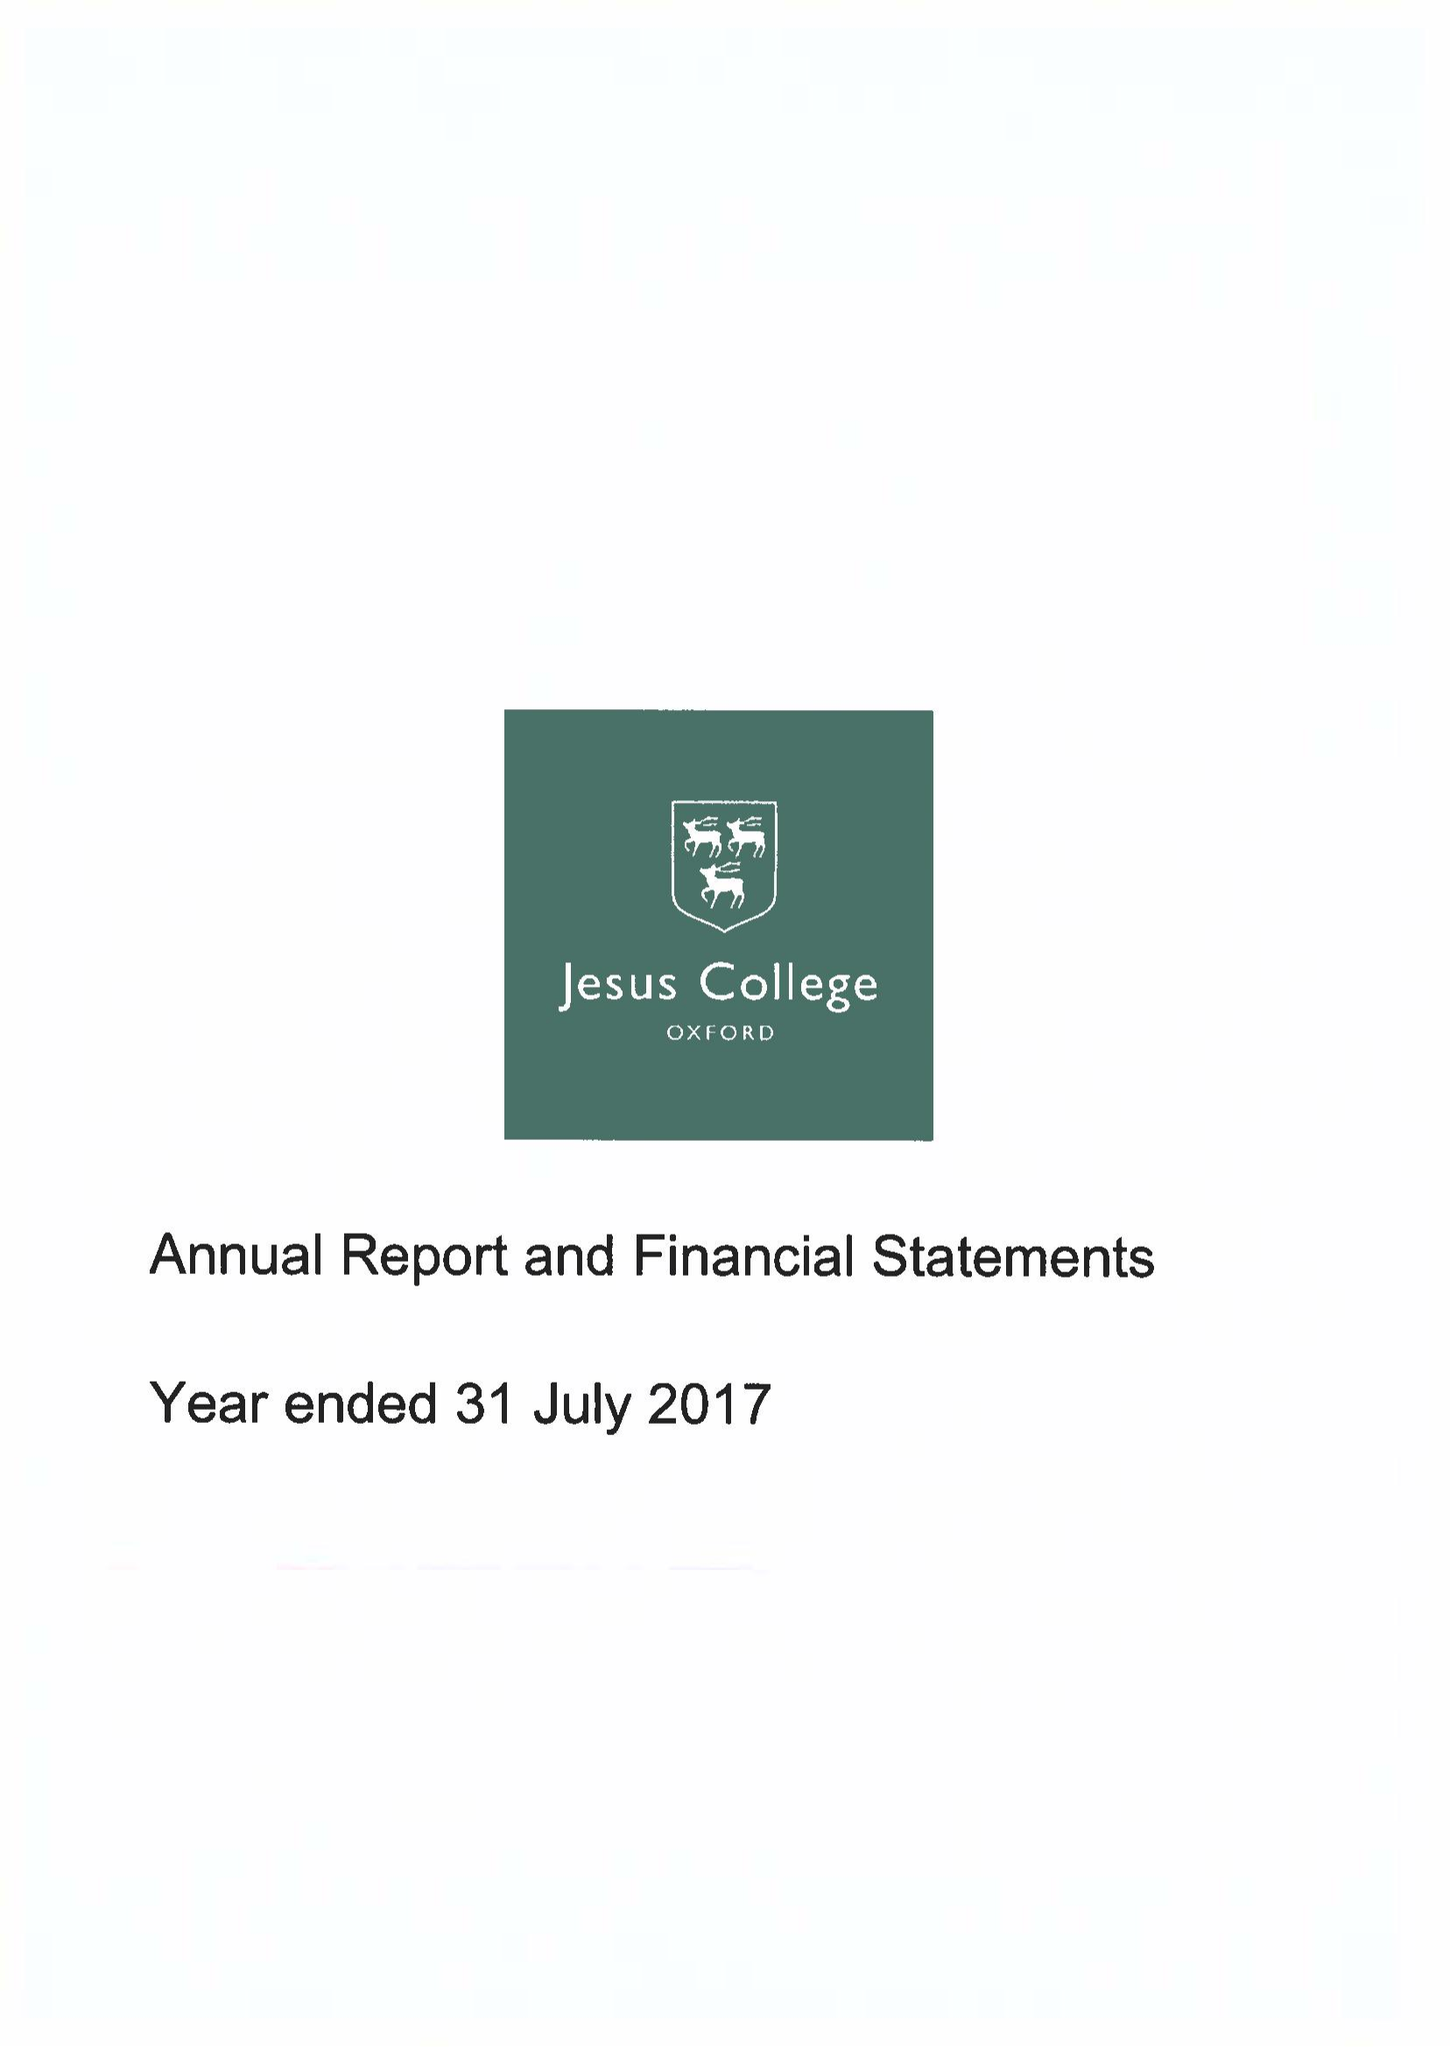What is the value for the charity_number?
Answer the question using a single word or phrase. 1137435 